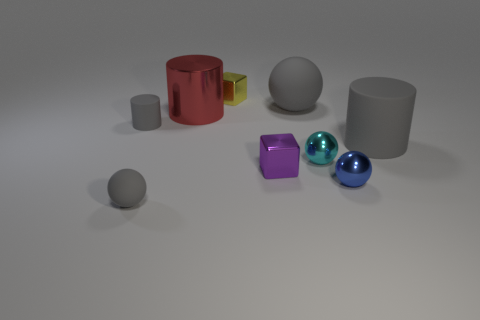Add 1 large red metallic cubes. How many objects exist? 10 Subtract all cylinders. How many objects are left? 6 Subtract 0 green cylinders. How many objects are left? 9 Subtract all small shiny balls. Subtract all gray matte things. How many objects are left? 3 Add 1 large red cylinders. How many large red cylinders are left? 2 Add 3 cyan metallic objects. How many cyan metallic objects exist? 4 